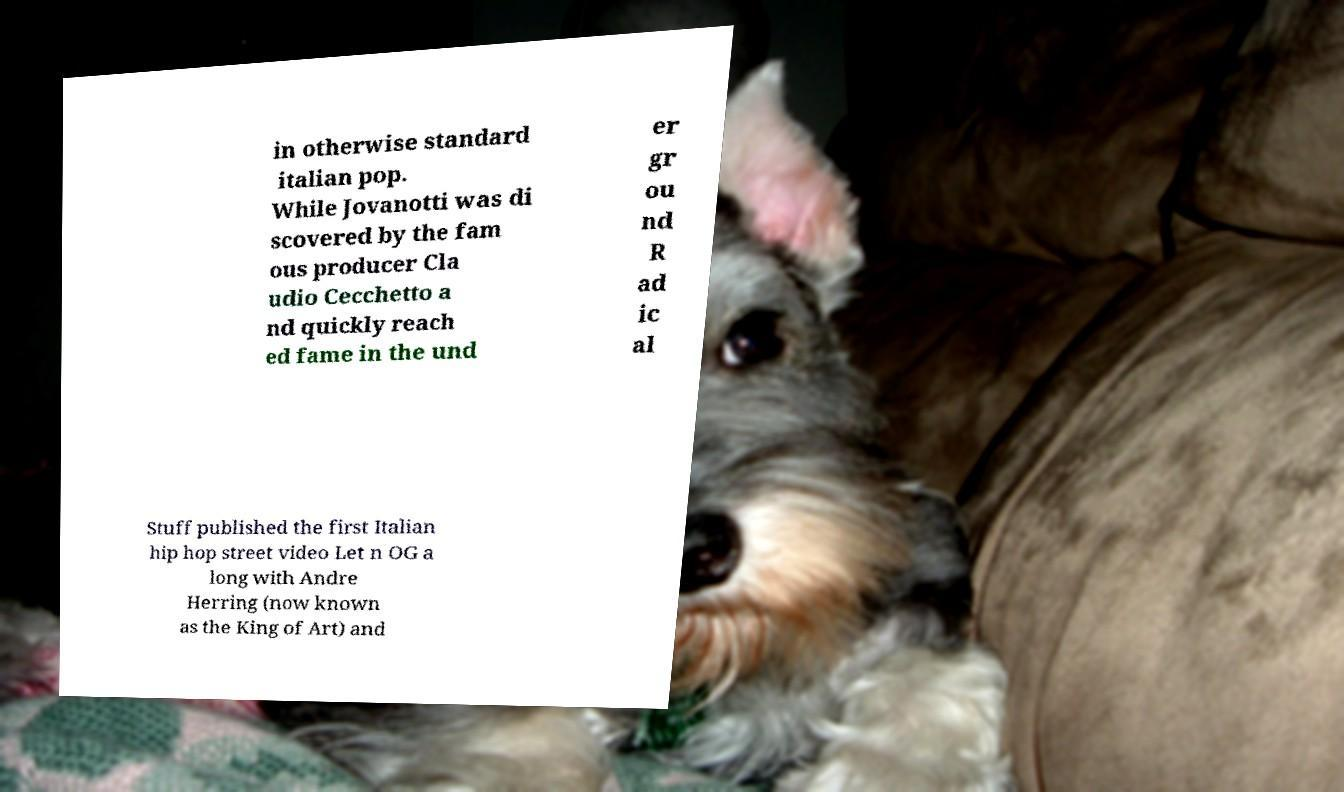Could you assist in decoding the text presented in this image and type it out clearly? in otherwise standard italian pop. While Jovanotti was di scovered by the fam ous producer Cla udio Cecchetto a nd quickly reach ed fame in the und er gr ou nd R ad ic al Stuff published the first Italian hip hop street video Let n OG a long with Andre Herring (now known as the King of Art) and 